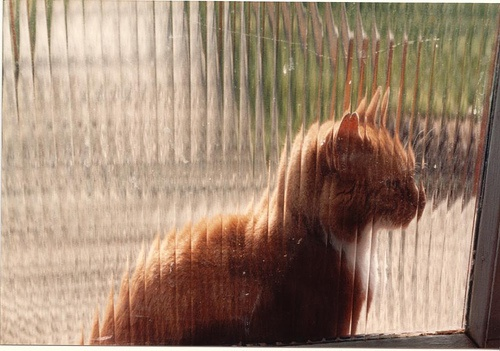Describe the objects in this image and their specific colors. I can see a cat in white, maroon, black, and brown tones in this image. 